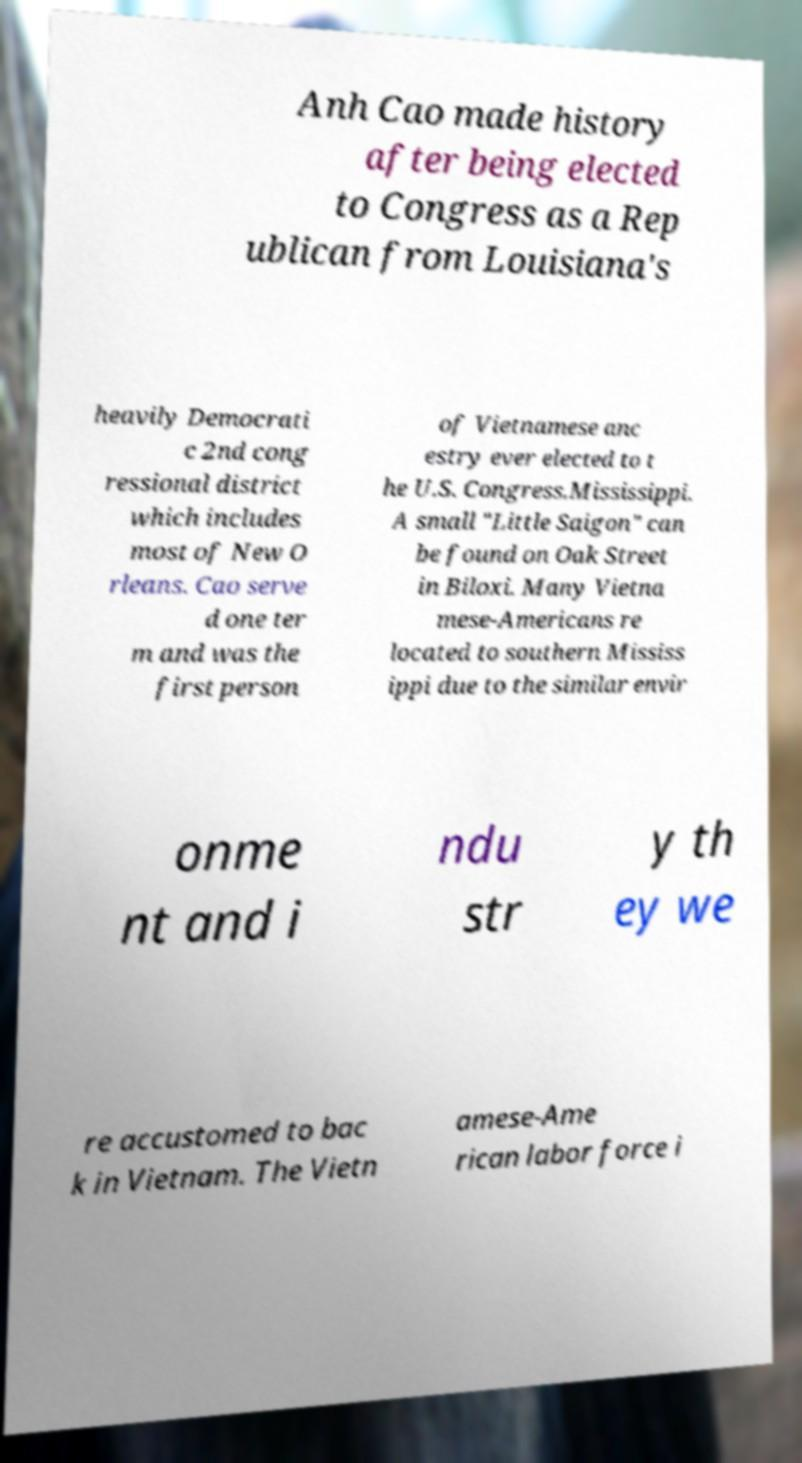Could you extract and type out the text from this image? Anh Cao made history after being elected to Congress as a Rep ublican from Louisiana's heavily Democrati c 2nd cong ressional district which includes most of New O rleans. Cao serve d one ter m and was the first person of Vietnamese anc estry ever elected to t he U.S. Congress.Mississippi. A small "Little Saigon" can be found on Oak Street in Biloxi. Many Vietna mese-Americans re located to southern Mississ ippi due to the similar envir onme nt and i ndu str y th ey we re accustomed to bac k in Vietnam. The Vietn amese-Ame rican labor force i 